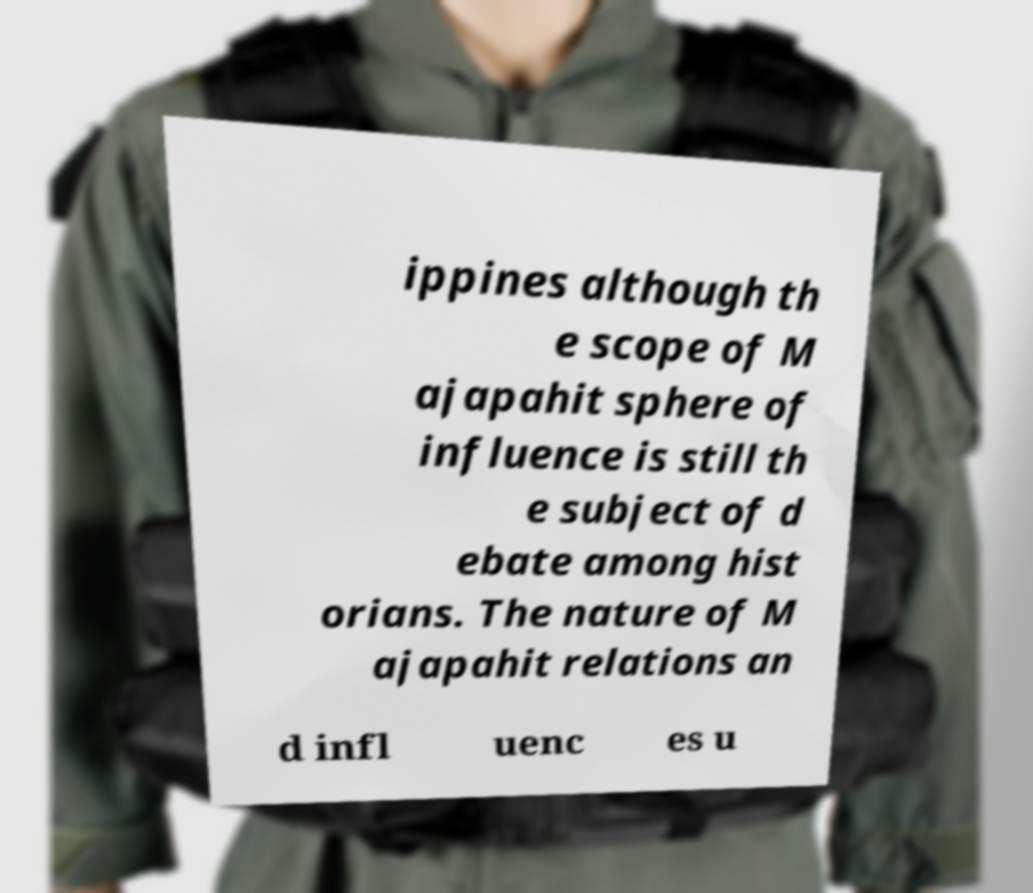Can you accurately transcribe the text from the provided image for me? ippines although th e scope of M ajapahit sphere of influence is still th e subject of d ebate among hist orians. The nature of M ajapahit relations an d infl uenc es u 